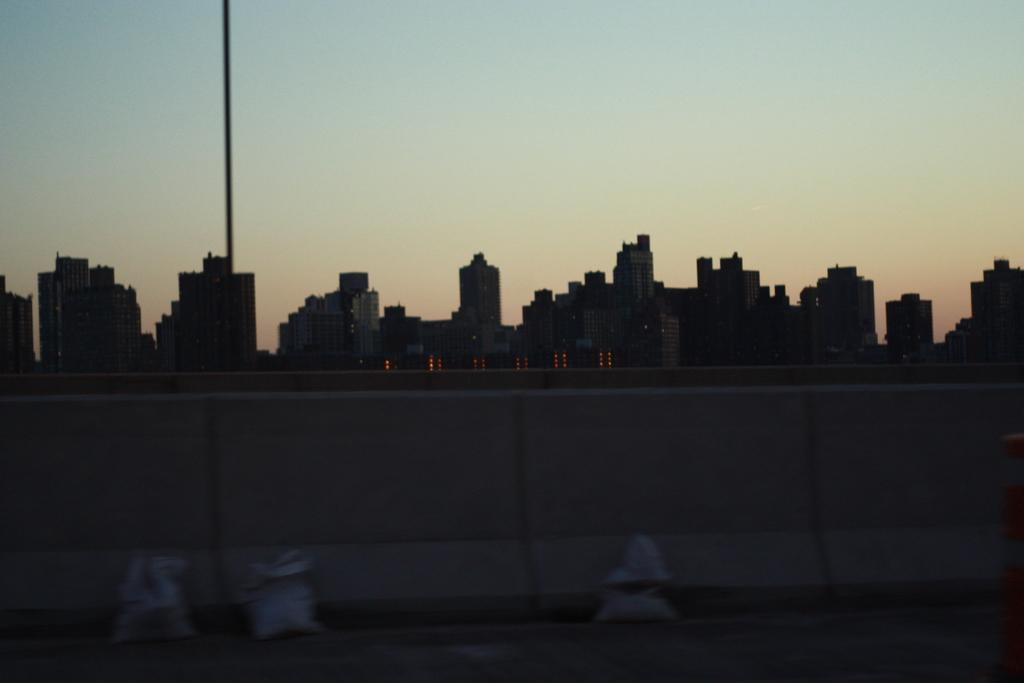Describe this image in one or two sentences. In this image I can see three white colour things and the wall in the front. In the background I can see a pole, number of buildings, lights and the sky. 